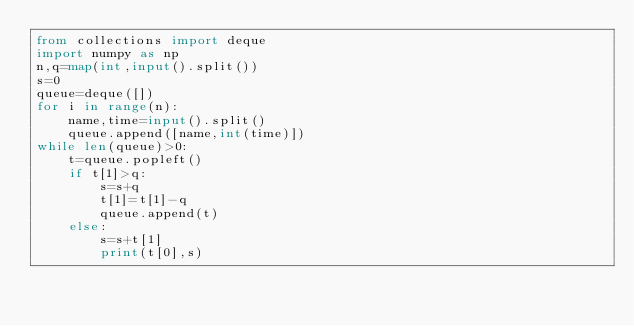<code> <loc_0><loc_0><loc_500><loc_500><_Python_>from collections import deque 
import numpy as np
n,q=map(int,input().split())
s=0
queue=deque([])
for i in range(n):
    name,time=input().split()
    queue.append([name,int(time)])
while len(queue)>0:
    t=queue.popleft()
    if t[1]>q:
        s=s+q
        t[1]=t[1]-q
        queue.append(t)
    else:
        s=s+t[1]
        print(t[0],s)
</code> 